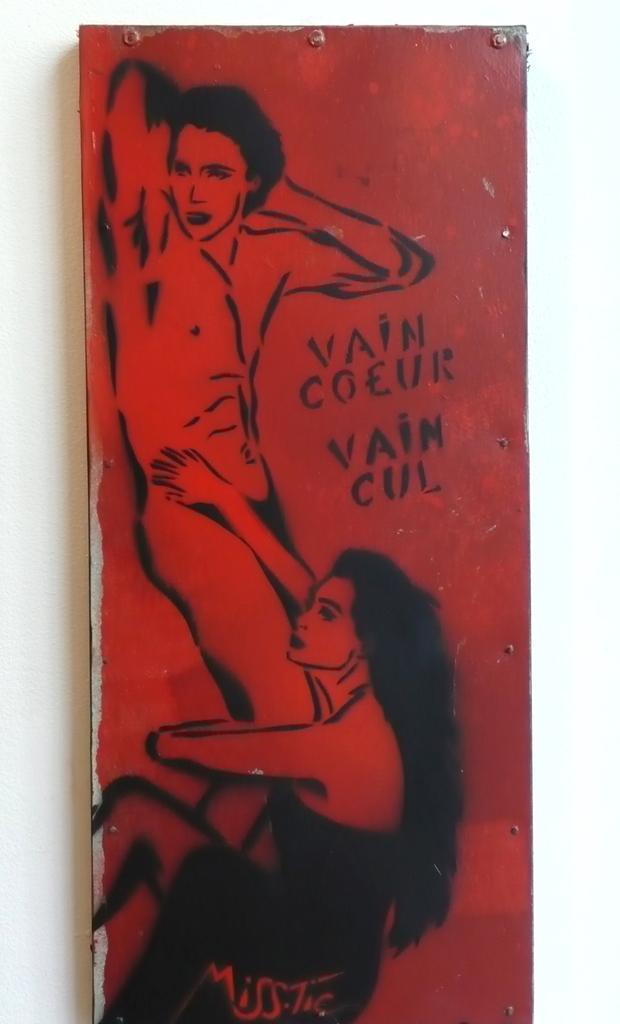How would you summarize this image in a sentence or two? In this image there is a painting on the metal piece. In the painting we can see that there is a man standing on the left side. At the bottom there is a woman who is holding the legs of a man. 